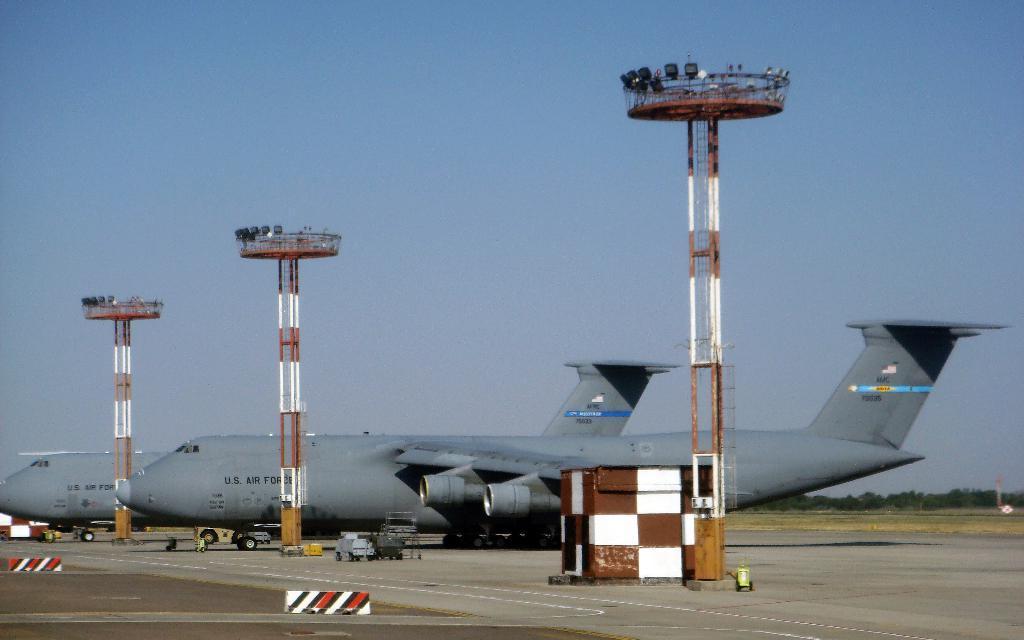Could you give a brief overview of what you see in this image? In this image there are poles and there are airplanes on the ground, there are vehicles. In the background there are trees. 